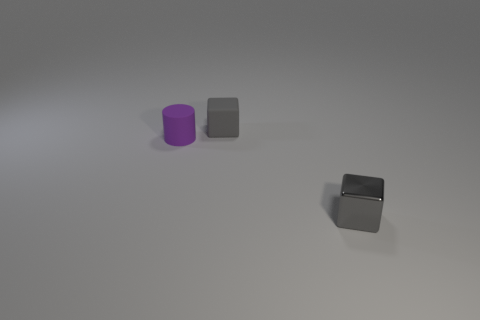There is a small shiny thing that is the same color as the small matte block; what shape is it?
Your response must be concise. Cube. What shape is the other object that is made of the same material as the tiny purple object?
Ensure brevity in your answer.  Cube. Is the tiny shiny thing the same shape as the tiny gray matte thing?
Ensure brevity in your answer.  Yes. What is the color of the matte cylinder?
Ensure brevity in your answer.  Purple. What number of objects are cyan cylinders or small cylinders?
Offer a very short reply. 1. Are there fewer tiny blocks that are on the left side of the small gray rubber thing than yellow metallic spheres?
Offer a very short reply. No. Are there more tiny blocks in front of the small purple object than cylinders that are on the right side of the small gray rubber thing?
Provide a short and direct response. Yes. Is there any other thing that has the same color as the tiny matte cylinder?
Offer a terse response. No. There is a gray thing that is behind the small purple cylinder; what is its material?
Provide a short and direct response. Rubber. Is the size of the metal block the same as the cylinder?
Make the answer very short. Yes. 